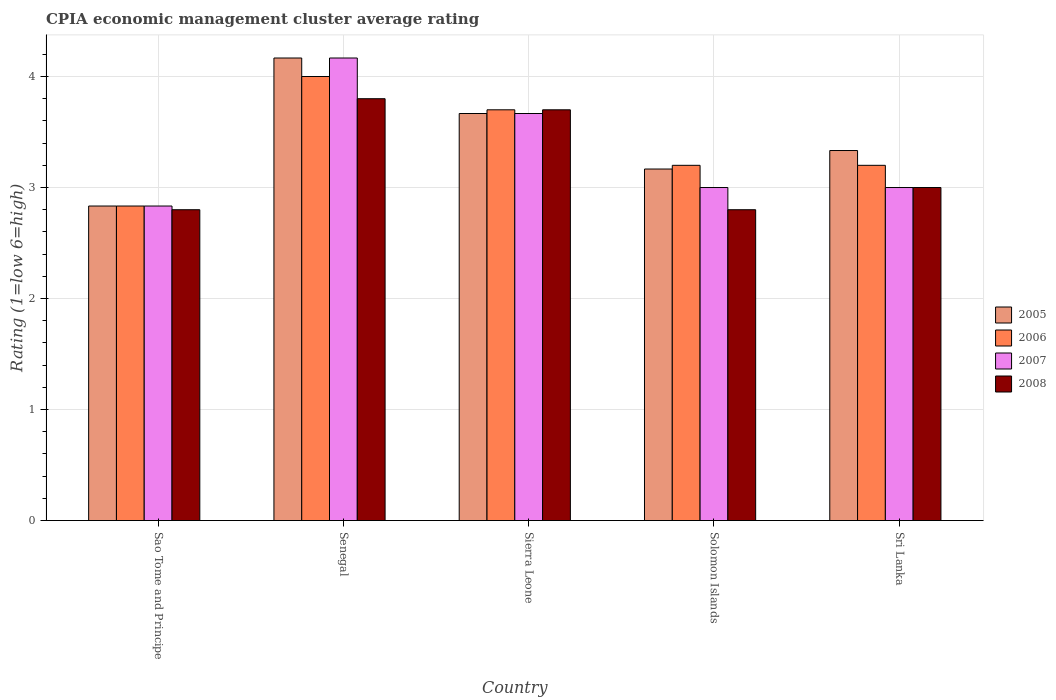What is the label of the 3rd group of bars from the left?
Give a very brief answer. Sierra Leone. Across all countries, what is the maximum CPIA rating in 2007?
Provide a succinct answer. 4.17. Across all countries, what is the minimum CPIA rating in 2007?
Keep it short and to the point. 2.83. In which country was the CPIA rating in 2005 maximum?
Your response must be concise. Senegal. In which country was the CPIA rating in 2007 minimum?
Your answer should be very brief. Sao Tome and Principe. What is the total CPIA rating in 2005 in the graph?
Give a very brief answer. 17.17. What is the difference between the CPIA rating in 2006 in Senegal and that in Sri Lanka?
Provide a succinct answer. 0.8. What is the difference between the CPIA rating in 2008 in Solomon Islands and the CPIA rating in 2006 in Sao Tome and Principe?
Your answer should be compact. -0.03. What is the average CPIA rating in 2008 per country?
Ensure brevity in your answer.  3.22. What is the difference between the CPIA rating of/in 2007 and CPIA rating of/in 2006 in Sierra Leone?
Keep it short and to the point. -0.03. What is the ratio of the CPIA rating in 2008 in Sao Tome and Principe to that in Sierra Leone?
Keep it short and to the point. 0.76. Is the CPIA rating in 2008 in Sierra Leone less than that in Solomon Islands?
Make the answer very short. No. Is the difference between the CPIA rating in 2007 in Senegal and Sri Lanka greater than the difference between the CPIA rating in 2006 in Senegal and Sri Lanka?
Provide a short and direct response. Yes. What is the difference between the highest and the lowest CPIA rating in 2007?
Ensure brevity in your answer.  1.33. In how many countries, is the CPIA rating in 2006 greater than the average CPIA rating in 2006 taken over all countries?
Your response must be concise. 2. Is it the case that in every country, the sum of the CPIA rating in 2005 and CPIA rating in 2008 is greater than the sum of CPIA rating in 2007 and CPIA rating in 2006?
Offer a terse response. No. What does the 4th bar from the left in Sierra Leone represents?
Ensure brevity in your answer.  2008. What does the 4th bar from the right in Sao Tome and Principe represents?
Ensure brevity in your answer.  2005. How many bars are there?
Make the answer very short. 20. Are all the bars in the graph horizontal?
Your answer should be very brief. No. How many countries are there in the graph?
Provide a short and direct response. 5. What is the difference between two consecutive major ticks on the Y-axis?
Keep it short and to the point. 1. Are the values on the major ticks of Y-axis written in scientific E-notation?
Offer a very short reply. No. Where does the legend appear in the graph?
Offer a very short reply. Center right. How are the legend labels stacked?
Make the answer very short. Vertical. What is the title of the graph?
Your answer should be very brief. CPIA economic management cluster average rating. Does "1983" appear as one of the legend labels in the graph?
Your answer should be very brief. No. What is the label or title of the X-axis?
Provide a succinct answer. Country. What is the label or title of the Y-axis?
Your response must be concise. Rating (1=low 6=high). What is the Rating (1=low 6=high) in 2005 in Sao Tome and Principe?
Offer a very short reply. 2.83. What is the Rating (1=low 6=high) of 2006 in Sao Tome and Principe?
Make the answer very short. 2.83. What is the Rating (1=low 6=high) in 2007 in Sao Tome and Principe?
Offer a very short reply. 2.83. What is the Rating (1=low 6=high) of 2008 in Sao Tome and Principe?
Provide a succinct answer. 2.8. What is the Rating (1=low 6=high) in 2005 in Senegal?
Your answer should be very brief. 4.17. What is the Rating (1=low 6=high) of 2006 in Senegal?
Give a very brief answer. 4. What is the Rating (1=low 6=high) of 2007 in Senegal?
Offer a very short reply. 4.17. What is the Rating (1=low 6=high) in 2005 in Sierra Leone?
Provide a short and direct response. 3.67. What is the Rating (1=low 6=high) of 2006 in Sierra Leone?
Offer a terse response. 3.7. What is the Rating (1=low 6=high) in 2007 in Sierra Leone?
Your response must be concise. 3.67. What is the Rating (1=low 6=high) of 2008 in Sierra Leone?
Make the answer very short. 3.7. What is the Rating (1=low 6=high) of 2005 in Solomon Islands?
Make the answer very short. 3.17. What is the Rating (1=low 6=high) of 2006 in Solomon Islands?
Your response must be concise. 3.2. What is the Rating (1=low 6=high) in 2007 in Solomon Islands?
Offer a terse response. 3. What is the Rating (1=low 6=high) in 2008 in Solomon Islands?
Your answer should be compact. 2.8. What is the Rating (1=low 6=high) in 2005 in Sri Lanka?
Your response must be concise. 3.33. What is the Rating (1=low 6=high) in 2006 in Sri Lanka?
Give a very brief answer. 3.2. Across all countries, what is the maximum Rating (1=low 6=high) in 2005?
Offer a terse response. 4.17. Across all countries, what is the maximum Rating (1=low 6=high) of 2006?
Provide a succinct answer. 4. Across all countries, what is the maximum Rating (1=low 6=high) in 2007?
Provide a succinct answer. 4.17. Across all countries, what is the minimum Rating (1=low 6=high) of 2005?
Provide a short and direct response. 2.83. Across all countries, what is the minimum Rating (1=low 6=high) of 2006?
Provide a succinct answer. 2.83. Across all countries, what is the minimum Rating (1=low 6=high) in 2007?
Your response must be concise. 2.83. Across all countries, what is the minimum Rating (1=low 6=high) of 2008?
Your answer should be compact. 2.8. What is the total Rating (1=low 6=high) of 2005 in the graph?
Ensure brevity in your answer.  17.17. What is the total Rating (1=low 6=high) of 2006 in the graph?
Offer a terse response. 16.93. What is the total Rating (1=low 6=high) of 2007 in the graph?
Give a very brief answer. 16.67. What is the difference between the Rating (1=low 6=high) in 2005 in Sao Tome and Principe and that in Senegal?
Your answer should be compact. -1.33. What is the difference between the Rating (1=low 6=high) of 2006 in Sao Tome and Principe and that in Senegal?
Provide a short and direct response. -1.17. What is the difference between the Rating (1=low 6=high) in 2007 in Sao Tome and Principe and that in Senegal?
Keep it short and to the point. -1.33. What is the difference between the Rating (1=low 6=high) in 2006 in Sao Tome and Principe and that in Sierra Leone?
Your answer should be compact. -0.87. What is the difference between the Rating (1=low 6=high) in 2007 in Sao Tome and Principe and that in Sierra Leone?
Offer a very short reply. -0.83. What is the difference between the Rating (1=low 6=high) of 2008 in Sao Tome and Principe and that in Sierra Leone?
Provide a succinct answer. -0.9. What is the difference between the Rating (1=low 6=high) of 2005 in Sao Tome and Principe and that in Solomon Islands?
Offer a very short reply. -0.33. What is the difference between the Rating (1=low 6=high) of 2006 in Sao Tome and Principe and that in Solomon Islands?
Ensure brevity in your answer.  -0.37. What is the difference between the Rating (1=low 6=high) in 2007 in Sao Tome and Principe and that in Solomon Islands?
Offer a terse response. -0.17. What is the difference between the Rating (1=low 6=high) in 2006 in Sao Tome and Principe and that in Sri Lanka?
Ensure brevity in your answer.  -0.37. What is the difference between the Rating (1=low 6=high) in 2006 in Senegal and that in Sierra Leone?
Ensure brevity in your answer.  0.3. What is the difference between the Rating (1=low 6=high) in 2005 in Senegal and that in Solomon Islands?
Offer a terse response. 1. What is the difference between the Rating (1=low 6=high) in 2006 in Senegal and that in Solomon Islands?
Provide a succinct answer. 0.8. What is the difference between the Rating (1=low 6=high) of 2006 in Senegal and that in Sri Lanka?
Offer a very short reply. 0.8. What is the difference between the Rating (1=low 6=high) of 2005 in Sierra Leone and that in Solomon Islands?
Offer a terse response. 0.5. What is the difference between the Rating (1=low 6=high) in 2006 in Sierra Leone and that in Solomon Islands?
Keep it short and to the point. 0.5. What is the difference between the Rating (1=low 6=high) of 2007 in Sierra Leone and that in Solomon Islands?
Offer a terse response. 0.67. What is the difference between the Rating (1=low 6=high) of 2008 in Sierra Leone and that in Solomon Islands?
Provide a succinct answer. 0.9. What is the difference between the Rating (1=low 6=high) of 2006 in Sierra Leone and that in Sri Lanka?
Offer a very short reply. 0.5. What is the difference between the Rating (1=low 6=high) of 2007 in Sierra Leone and that in Sri Lanka?
Your response must be concise. 0.67. What is the difference between the Rating (1=low 6=high) in 2008 in Sierra Leone and that in Sri Lanka?
Provide a short and direct response. 0.7. What is the difference between the Rating (1=low 6=high) of 2005 in Solomon Islands and that in Sri Lanka?
Make the answer very short. -0.17. What is the difference between the Rating (1=low 6=high) of 2008 in Solomon Islands and that in Sri Lanka?
Make the answer very short. -0.2. What is the difference between the Rating (1=low 6=high) in 2005 in Sao Tome and Principe and the Rating (1=low 6=high) in 2006 in Senegal?
Give a very brief answer. -1.17. What is the difference between the Rating (1=low 6=high) in 2005 in Sao Tome and Principe and the Rating (1=low 6=high) in 2007 in Senegal?
Provide a succinct answer. -1.33. What is the difference between the Rating (1=low 6=high) of 2005 in Sao Tome and Principe and the Rating (1=low 6=high) of 2008 in Senegal?
Give a very brief answer. -0.97. What is the difference between the Rating (1=low 6=high) in 2006 in Sao Tome and Principe and the Rating (1=low 6=high) in 2007 in Senegal?
Your answer should be compact. -1.33. What is the difference between the Rating (1=low 6=high) in 2006 in Sao Tome and Principe and the Rating (1=low 6=high) in 2008 in Senegal?
Your answer should be very brief. -0.97. What is the difference between the Rating (1=low 6=high) in 2007 in Sao Tome and Principe and the Rating (1=low 6=high) in 2008 in Senegal?
Your response must be concise. -0.97. What is the difference between the Rating (1=low 6=high) in 2005 in Sao Tome and Principe and the Rating (1=low 6=high) in 2006 in Sierra Leone?
Give a very brief answer. -0.87. What is the difference between the Rating (1=low 6=high) of 2005 in Sao Tome and Principe and the Rating (1=low 6=high) of 2007 in Sierra Leone?
Provide a succinct answer. -0.83. What is the difference between the Rating (1=low 6=high) of 2005 in Sao Tome and Principe and the Rating (1=low 6=high) of 2008 in Sierra Leone?
Keep it short and to the point. -0.87. What is the difference between the Rating (1=low 6=high) in 2006 in Sao Tome and Principe and the Rating (1=low 6=high) in 2008 in Sierra Leone?
Your answer should be compact. -0.87. What is the difference between the Rating (1=low 6=high) in 2007 in Sao Tome and Principe and the Rating (1=low 6=high) in 2008 in Sierra Leone?
Ensure brevity in your answer.  -0.87. What is the difference between the Rating (1=low 6=high) of 2005 in Sao Tome and Principe and the Rating (1=low 6=high) of 2006 in Solomon Islands?
Keep it short and to the point. -0.37. What is the difference between the Rating (1=low 6=high) in 2007 in Sao Tome and Principe and the Rating (1=low 6=high) in 2008 in Solomon Islands?
Ensure brevity in your answer.  0.03. What is the difference between the Rating (1=low 6=high) of 2005 in Sao Tome and Principe and the Rating (1=low 6=high) of 2006 in Sri Lanka?
Ensure brevity in your answer.  -0.37. What is the difference between the Rating (1=low 6=high) in 2005 in Sao Tome and Principe and the Rating (1=low 6=high) in 2007 in Sri Lanka?
Offer a very short reply. -0.17. What is the difference between the Rating (1=low 6=high) in 2006 in Sao Tome and Principe and the Rating (1=low 6=high) in 2008 in Sri Lanka?
Provide a succinct answer. -0.17. What is the difference between the Rating (1=low 6=high) of 2005 in Senegal and the Rating (1=low 6=high) of 2006 in Sierra Leone?
Make the answer very short. 0.47. What is the difference between the Rating (1=low 6=high) of 2005 in Senegal and the Rating (1=low 6=high) of 2008 in Sierra Leone?
Make the answer very short. 0.47. What is the difference between the Rating (1=low 6=high) in 2006 in Senegal and the Rating (1=low 6=high) in 2008 in Sierra Leone?
Keep it short and to the point. 0.3. What is the difference between the Rating (1=low 6=high) of 2007 in Senegal and the Rating (1=low 6=high) of 2008 in Sierra Leone?
Offer a very short reply. 0.47. What is the difference between the Rating (1=low 6=high) of 2005 in Senegal and the Rating (1=low 6=high) of 2006 in Solomon Islands?
Your answer should be compact. 0.97. What is the difference between the Rating (1=low 6=high) of 2005 in Senegal and the Rating (1=low 6=high) of 2008 in Solomon Islands?
Make the answer very short. 1.37. What is the difference between the Rating (1=low 6=high) of 2006 in Senegal and the Rating (1=low 6=high) of 2007 in Solomon Islands?
Ensure brevity in your answer.  1. What is the difference between the Rating (1=low 6=high) in 2007 in Senegal and the Rating (1=low 6=high) in 2008 in Solomon Islands?
Ensure brevity in your answer.  1.37. What is the difference between the Rating (1=low 6=high) in 2005 in Senegal and the Rating (1=low 6=high) in 2006 in Sri Lanka?
Your response must be concise. 0.97. What is the difference between the Rating (1=low 6=high) of 2005 in Senegal and the Rating (1=low 6=high) of 2007 in Sri Lanka?
Provide a succinct answer. 1.17. What is the difference between the Rating (1=low 6=high) in 2006 in Senegal and the Rating (1=low 6=high) in 2008 in Sri Lanka?
Keep it short and to the point. 1. What is the difference between the Rating (1=low 6=high) of 2007 in Senegal and the Rating (1=low 6=high) of 2008 in Sri Lanka?
Ensure brevity in your answer.  1.17. What is the difference between the Rating (1=low 6=high) in 2005 in Sierra Leone and the Rating (1=low 6=high) in 2006 in Solomon Islands?
Your response must be concise. 0.47. What is the difference between the Rating (1=low 6=high) of 2005 in Sierra Leone and the Rating (1=low 6=high) of 2007 in Solomon Islands?
Offer a terse response. 0.67. What is the difference between the Rating (1=low 6=high) of 2005 in Sierra Leone and the Rating (1=low 6=high) of 2008 in Solomon Islands?
Your response must be concise. 0.87. What is the difference between the Rating (1=low 6=high) of 2006 in Sierra Leone and the Rating (1=low 6=high) of 2007 in Solomon Islands?
Keep it short and to the point. 0.7. What is the difference between the Rating (1=low 6=high) of 2007 in Sierra Leone and the Rating (1=low 6=high) of 2008 in Solomon Islands?
Make the answer very short. 0.87. What is the difference between the Rating (1=low 6=high) in 2005 in Sierra Leone and the Rating (1=low 6=high) in 2006 in Sri Lanka?
Offer a terse response. 0.47. What is the difference between the Rating (1=low 6=high) in 2005 in Sierra Leone and the Rating (1=low 6=high) in 2007 in Sri Lanka?
Make the answer very short. 0.67. What is the difference between the Rating (1=low 6=high) of 2006 in Sierra Leone and the Rating (1=low 6=high) of 2007 in Sri Lanka?
Give a very brief answer. 0.7. What is the difference between the Rating (1=low 6=high) of 2006 in Sierra Leone and the Rating (1=low 6=high) of 2008 in Sri Lanka?
Give a very brief answer. 0.7. What is the difference between the Rating (1=low 6=high) in 2007 in Sierra Leone and the Rating (1=low 6=high) in 2008 in Sri Lanka?
Provide a short and direct response. 0.67. What is the difference between the Rating (1=low 6=high) in 2005 in Solomon Islands and the Rating (1=low 6=high) in 2006 in Sri Lanka?
Offer a terse response. -0.03. What is the difference between the Rating (1=low 6=high) of 2005 in Solomon Islands and the Rating (1=low 6=high) of 2007 in Sri Lanka?
Offer a terse response. 0.17. What is the difference between the Rating (1=low 6=high) of 2006 in Solomon Islands and the Rating (1=low 6=high) of 2007 in Sri Lanka?
Your response must be concise. 0.2. What is the difference between the Rating (1=low 6=high) of 2006 in Solomon Islands and the Rating (1=low 6=high) of 2008 in Sri Lanka?
Give a very brief answer. 0.2. What is the difference between the Rating (1=low 6=high) in 2007 in Solomon Islands and the Rating (1=low 6=high) in 2008 in Sri Lanka?
Keep it short and to the point. 0. What is the average Rating (1=low 6=high) of 2005 per country?
Ensure brevity in your answer.  3.43. What is the average Rating (1=low 6=high) of 2006 per country?
Ensure brevity in your answer.  3.39. What is the average Rating (1=low 6=high) in 2007 per country?
Your answer should be very brief. 3.33. What is the average Rating (1=low 6=high) of 2008 per country?
Provide a succinct answer. 3.22. What is the difference between the Rating (1=low 6=high) in 2005 and Rating (1=low 6=high) in 2007 in Sao Tome and Principe?
Your answer should be very brief. 0. What is the difference between the Rating (1=low 6=high) in 2005 and Rating (1=low 6=high) in 2008 in Sao Tome and Principe?
Provide a short and direct response. 0.03. What is the difference between the Rating (1=low 6=high) in 2005 and Rating (1=low 6=high) in 2007 in Senegal?
Your answer should be very brief. 0. What is the difference between the Rating (1=low 6=high) of 2005 and Rating (1=low 6=high) of 2008 in Senegal?
Offer a very short reply. 0.37. What is the difference between the Rating (1=low 6=high) of 2006 and Rating (1=low 6=high) of 2007 in Senegal?
Your answer should be very brief. -0.17. What is the difference between the Rating (1=low 6=high) of 2006 and Rating (1=low 6=high) of 2008 in Senegal?
Offer a terse response. 0.2. What is the difference between the Rating (1=low 6=high) in 2007 and Rating (1=low 6=high) in 2008 in Senegal?
Your answer should be compact. 0.37. What is the difference between the Rating (1=low 6=high) in 2005 and Rating (1=low 6=high) in 2006 in Sierra Leone?
Provide a succinct answer. -0.03. What is the difference between the Rating (1=low 6=high) in 2005 and Rating (1=low 6=high) in 2008 in Sierra Leone?
Keep it short and to the point. -0.03. What is the difference between the Rating (1=low 6=high) of 2006 and Rating (1=low 6=high) of 2007 in Sierra Leone?
Your response must be concise. 0.03. What is the difference between the Rating (1=low 6=high) in 2006 and Rating (1=low 6=high) in 2008 in Sierra Leone?
Give a very brief answer. 0. What is the difference between the Rating (1=low 6=high) in 2007 and Rating (1=low 6=high) in 2008 in Sierra Leone?
Your answer should be very brief. -0.03. What is the difference between the Rating (1=low 6=high) of 2005 and Rating (1=low 6=high) of 2006 in Solomon Islands?
Offer a very short reply. -0.03. What is the difference between the Rating (1=low 6=high) in 2005 and Rating (1=low 6=high) in 2007 in Solomon Islands?
Your answer should be compact. 0.17. What is the difference between the Rating (1=low 6=high) of 2005 and Rating (1=low 6=high) of 2008 in Solomon Islands?
Make the answer very short. 0.37. What is the difference between the Rating (1=low 6=high) of 2006 and Rating (1=low 6=high) of 2008 in Solomon Islands?
Make the answer very short. 0.4. What is the difference between the Rating (1=low 6=high) of 2005 and Rating (1=low 6=high) of 2006 in Sri Lanka?
Your answer should be very brief. 0.13. What is the difference between the Rating (1=low 6=high) in 2005 and Rating (1=low 6=high) in 2007 in Sri Lanka?
Keep it short and to the point. 0.33. What is the difference between the Rating (1=low 6=high) of 2006 and Rating (1=low 6=high) of 2007 in Sri Lanka?
Provide a short and direct response. 0.2. What is the difference between the Rating (1=low 6=high) of 2006 and Rating (1=low 6=high) of 2008 in Sri Lanka?
Provide a succinct answer. 0.2. What is the ratio of the Rating (1=low 6=high) in 2005 in Sao Tome and Principe to that in Senegal?
Your response must be concise. 0.68. What is the ratio of the Rating (1=low 6=high) of 2006 in Sao Tome and Principe to that in Senegal?
Provide a succinct answer. 0.71. What is the ratio of the Rating (1=low 6=high) in 2007 in Sao Tome and Principe to that in Senegal?
Offer a terse response. 0.68. What is the ratio of the Rating (1=low 6=high) of 2008 in Sao Tome and Principe to that in Senegal?
Give a very brief answer. 0.74. What is the ratio of the Rating (1=low 6=high) of 2005 in Sao Tome and Principe to that in Sierra Leone?
Ensure brevity in your answer.  0.77. What is the ratio of the Rating (1=low 6=high) of 2006 in Sao Tome and Principe to that in Sierra Leone?
Your answer should be very brief. 0.77. What is the ratio of the Rating (1=low 6=high) of 2007 in Sao Tome and Principe to that in Sierra Leone?
Provide a succinct answer. 0.77. What is the ratio of the Rating (1=low 6=high) in 2008 in Sao Tome and Principe to that in Sierra Leone?
Your answer should be compact. 0.76. What is the ratio of the Rating (1=low 6=high) of 2005 in Sao Tome and Principe to that in Solomon Islands?
Ensure brevity in your answer.  0.89. What is the ratio of the Rating (1=low 6=high) of 2006 in Sao Tome and Principe to that in Solomon Islands?
Offer a terse response. 0.89. What is the ratio of the Rating (1=low 6=high) of 2007 in Sao Tome and Principe to that in Solomon Islands?
Provide a succinct answer. 0.94. What is the ratio of the Rating (1=low 6=high) in 2008 in Sao Tome and Principe to that in Solomon Islands?
Offer a terse response. 1. What is the ratio of the Rating (1=low 6=high) in 2005 in Sao Tome and Principe to that in Sri Lanka?
Offer a terse response. 0.85. What is the ratio of the Rating (1=low 6=high) of 2006 in Sao Tome and Principe to that in Sri Lanka?
Provide a short and direct response. 0.89. What is the ratio of the Rating (1=low 6=high) in 2007 in Sao Tome and Principe to that in Sri Lanka?
Offer a very short reply. 0.94. What is the ratio of the Rating (1=low 6=high) in 2005 in Senegal to that in Sierra Leone?
Your answer should be compact. 1.14. What is the ratio of the Rating (1=low 6=high) of 2006 in Senegal to that in Sierra Leone?
Make the answer very short. 1.08. What is the ratio of the Rating (1=low 6=high) in 2007 in Senegal to that in Sierra Leone?
Offer a very short reply. 1.14. What is the ratio of the Rating (1=low 6=high) in 2008 in Senegal to that in Sierra Leone?
Provide a succinct answer. 1.03. What is the ratio of the Rating (1=low 6=high) of 2005 in Senegal to that in Solomon Islands?
Offer a very short reply. 1.32. What is the ratio of the Rating (1=low 6=high) of 2007 in Senegal to that in Solomon Islands?
Offer a very short reply. 1.39. What is the ratio of the Rating (1=low 6=high) of 2008 in Senegal to that in Solomon Islands?
Make the answer very short. 1.36. What is the ratio of the Rating (1=low 6=high) in 2006 in Senegal to that in Sri Lanka?
Make the answer very short. 1.25. What is the ratio of the Rating (1=low 6=high) of 2007 in Senegal to that in Sri Lanka?
Your answer should be compact. 1.39. What is the ratio of the Rating (1=low 6=high) in 2008 in Senegal to that in Sri Lanka?
Your response must be concise. 1.27. What is the ratio of the Rating (1=low 6=high) of 2005 in Sierra Leone to that in Solomon Islands?
Your answer should be compact. 1.16. What is the ratio of the Rating (1=low 6=high) in 2006 in Sierra Leone to that in Solomon Islands?
Give a very brief answer. 1.16. What is the ratio of the Rating (1=low 6=high) in 2007 in Sierra Leone to that in Solomon Islands?
Make the answer very short. 1.22. What is the ratio of the Rating (1=low 6=high) of 2008 in Sierra Leone to that in Solomon Islands?
Offer a very short reply. 1.32. What is the ratio of the Rating (1=low 6=high) of 2005 in Sierra Leone to that in Sri Lanka?
Your answer should be compact. 1.1. What is the ratio of the Rating (1=low 6=high) of 2006 in Sierra Leone to that in Sri Lanka?
Your answer should be compact. 1.16. What is the ratio of the Rating (1=low 6=high) of 2007 in Sierra Leone to that in Sri Lanka?
Ensure brevity in your answer.  1.22. What is the ratio of the Rating (1=low 6=high) in 2008 in Sierra Leone to that in Sri Lanka?
Offer a terse response. 1.23. What is the ratio of the Rating (1=low 6=high) of 2006 in Solomon Islands to that in Sri Lanka?
Ensure brevity in your answer.  1. What is the ratio of the Rating (1=low 6=high) of 2008 in Solomon Islands to that in Sri Lanka?
Your answer should be compact. 0.93. What is the difference between the highest and the second highest Rating (1=low 6=high) in 2005?
Provide a short and direct response. 0.5. What is the difference between the highest and the second highest Rating (1=low 6=high) of 2007?
Provide a succinct answer. 0.5. What is the difference between the highest and the lowest Rating (1=low 6=high) in 2005?
Offer a terse response. 1.33. What is the difference between the highest and the lowest Rating (1=low 6=high) of 2006?
Give a very brief answer. 1.17. What is the difference between the highest and the lowest Rating (1=low 6=high) of 2007?
Your answer should be very brief. 1.33. 